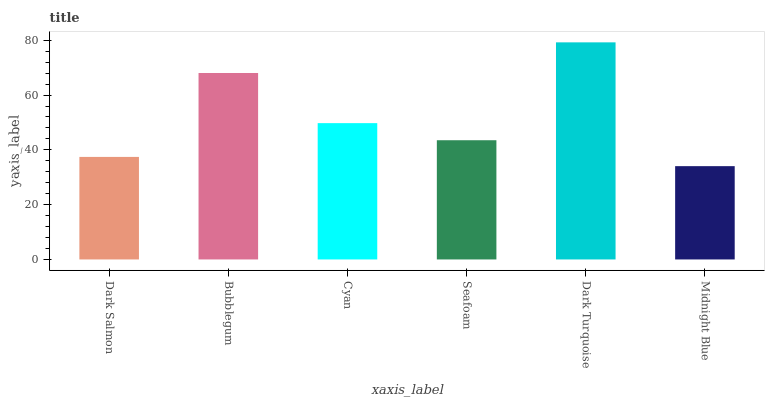Is Midnight Blue the minimum?
Answer yes or no. Yes. Is Dark Turquoise the maximum?
Answer yes or no. Yes. Is Bubblegum the minimum?
Answer yes or no. No. Is Bubblegum the maximum?
Answer yes or no. No. Is Bubblegum greater than Dark Salmon?
Answer yes or no. Yes. Is Dark Salmon less than Bubblegum?
Answer yes or no. Yes. Is Dark Salmon greater than Bubblegum?
Answer yes or no. No. Is Bubblegum less than Dark Salmon?
Answer yes or no. No. Is Cyan the high median?
Answer yes or no. Yes. Is Seafoam the low median?
Answer yes or no. Yes. Is Dark Turquoise the high median?
Answer yes or no. No. Is Bubblegum the low median?
Answer yes or no. No. 